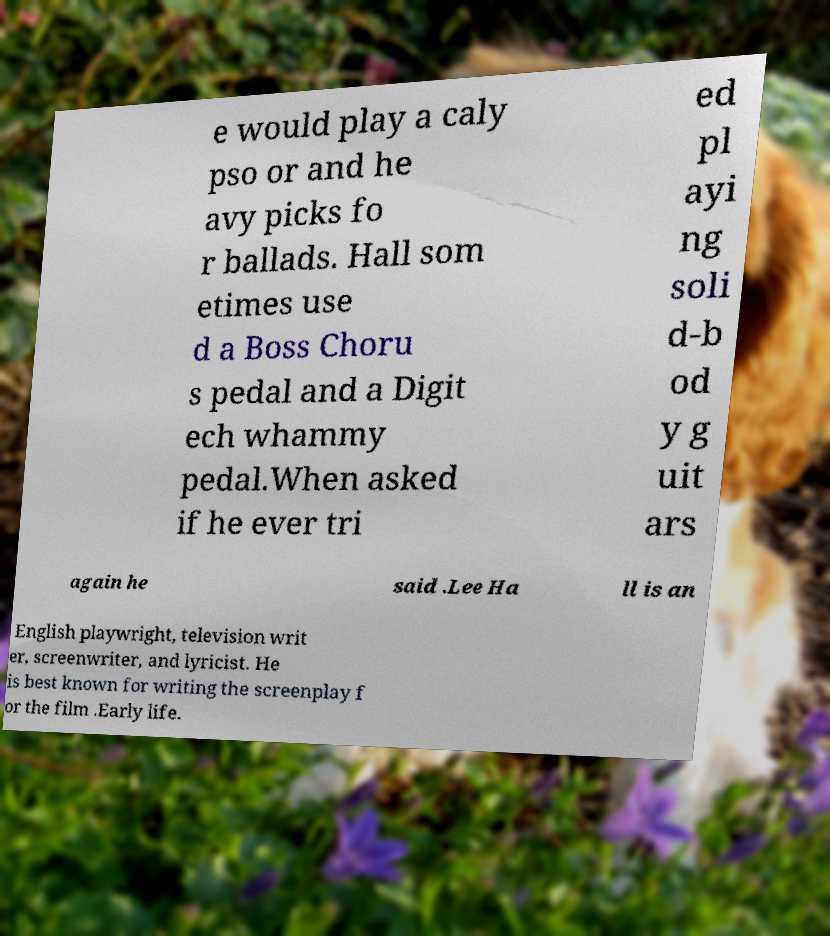I need the written content from this picture converted into text. Can you do that? e would play a caly pso or and he avy picks fo r ballads. Hall som etimes use d a Boss Choru s pedal and a Digit ech whammy pedal.When asked if he ever tri ed pl ayi ng soli d-b od y g uit ars again he said .Lee Ha ll is an English playwright, television writ er, screenwriter, and lyricist. He is best known for writing the screenplay f or the film .Early life. 